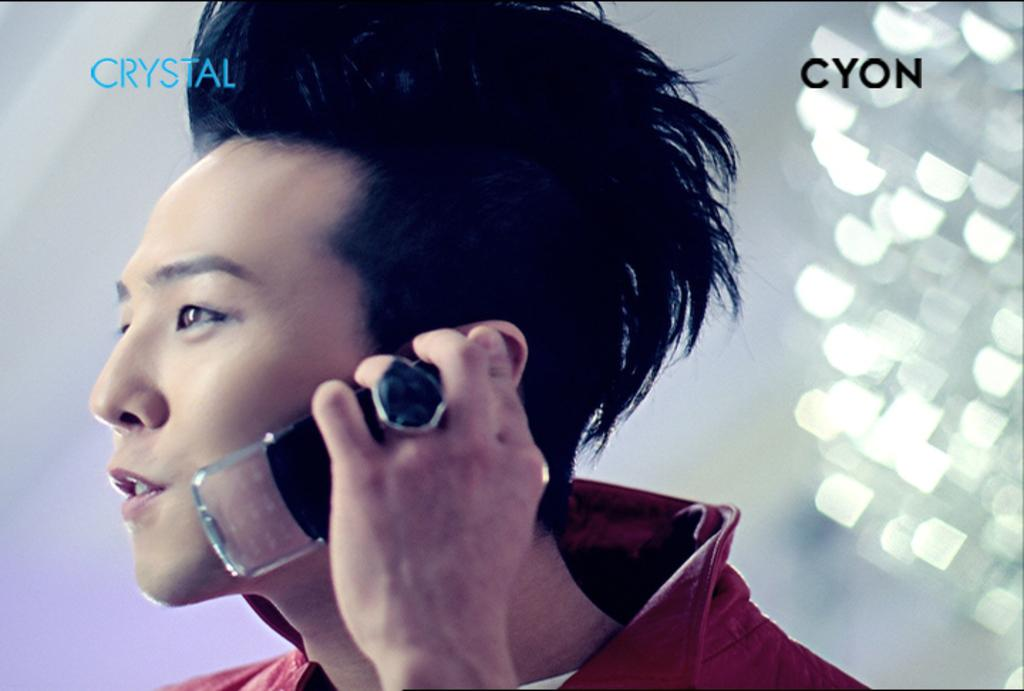Provide a one-sentence caption for the provided image. An advertisement of an Asian man holding a Crystal Cyon cellphone. 